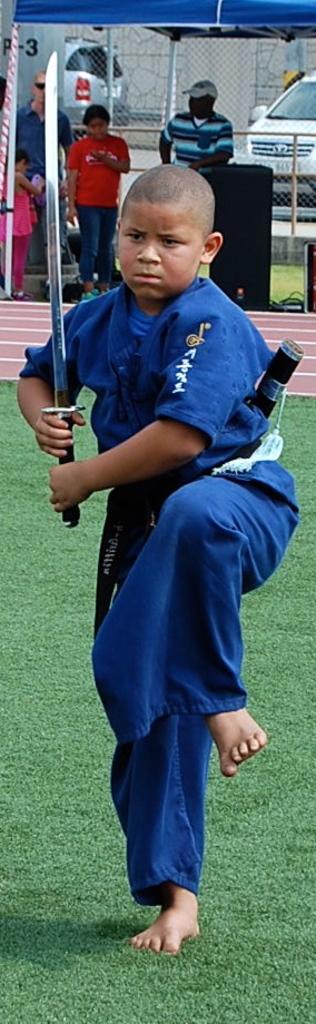In one or two sentences, can you explain what this image depicts? In this image there is a boy he is holding a sword in his hands, in the background there are people under the tent and there are cars. 